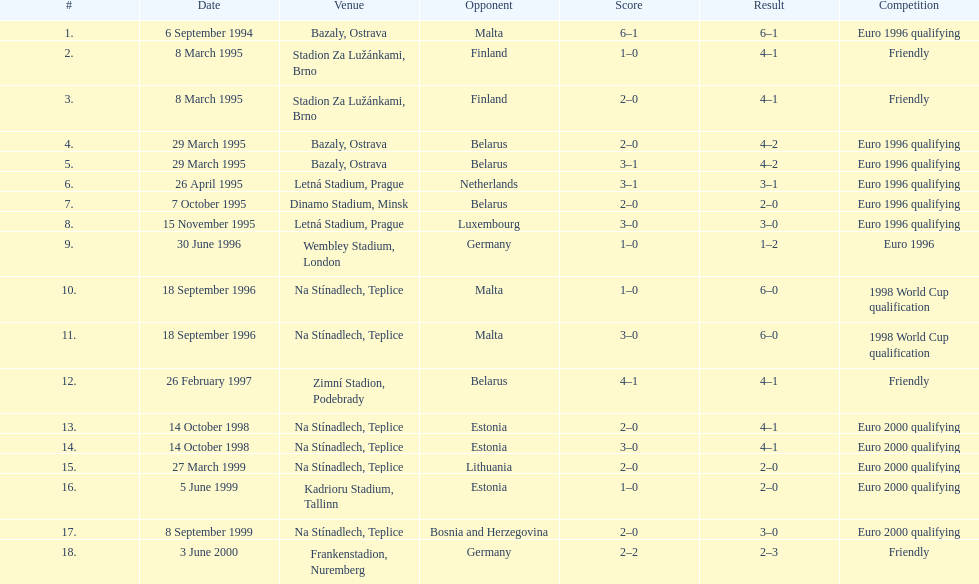Enumerate the rivals engaged in the cordial rivalry. Finland, Belarus, Germany. Could you parse the entire table as a dict? {'header': ['#', 'Date', 'Venue', 'Opponent', 'Score', 'Result', 'Competition'], 'rows': [['1.', '6 September 1994', 'Bazaly, Ostrava', 'Malta', '6–1', '6–1', 'Euro 1996 qualifying'], ['2.', '8 March 1995', 'Stadion Za Lužánkami, Brno', 'Finland', '1–0', '4–1', 'Friendly'], ['3.', '8 March 1995', 'Stadion Za Lužánkami, Brno', 'Finland', '2–0', '4–1', 'Friendly'], ['4.', '29 March 1995', 'Bazaly, Ostrava', 'Belarus', '2–0', '4–2', 'Euro 1996 qualifying'], ['5.', '29 March 1995', 'Bazaly, Ostrava', 'Belarus', '3–1', '4–2', 'Euro 1996 qualifying'], ['6.', '26 April 1995', 'Letná Stadium, Prague', 'Netherlands', '3–1', '3–1', 'Euro 1996 qualifying'], ['7.', '7 October 1995', 'Dinamo Stadium, Minsk', 'Belarus', '2–0', '2–0', 'Euro 1996 qualifying'], ['8.', '15 November 1995', 'Letná Stadium, Prague', 'Luxembourg', '3–0', '3–0', 'Euro 1996 qualifying'], ['9.', '30 June 1996', 'Wembley Stadium, London', 'Germany', '1–0', '1–2', 'Euro 1996'], ['10.', '18 September 1996', 'Na Stínadlech, Teplice', 'Malta', '1–0', '6–0', '1998 World Cup qualification'], ['11.', '18 September 1996', 'Na Stínadlech, Teplice', 'Malta', '3–0', '6–0', '1998 World Cup qualification'], ['12.', '26 February 1997', 'Zimní Stadion, Podebrady', 'Belarus', '4–1', '4–1', 'Friendly'], ['13.', '14 October 1998', 'Na Stínadlech, Teplice', 'Estonia', '2–0', '4–1', 'Euro 2000 qualifying'], ['14.', '14 October 1998', 'Na Stínadlech, Teplice', 'Estonia', '3–0', '4–1', 'Euro 2000 qualifying'], ['15.', '27 March 1999', 'Na Stínadlech, Teplice', 'Lithuania', '2–0', '2–0', 'Euro 2000 qualifying'], ['16.', '5 June 1999', 'Kadrioru Stadium, Tallinn', 'Estonia', '1–0', '2–0', 'Euro 2000 qualifying'], ['17.', '8 September 1999', 'Na Stínadlech, Teplice', 'Bosnia and Herzegovina', '2–0', '3–0', 'Euro 2000 qualifying'], ['18.', '3 June 2000', 'Frankenstadion, Nuremberg', 'Germany', '2–2', '2–3', 'Friendly']]} 